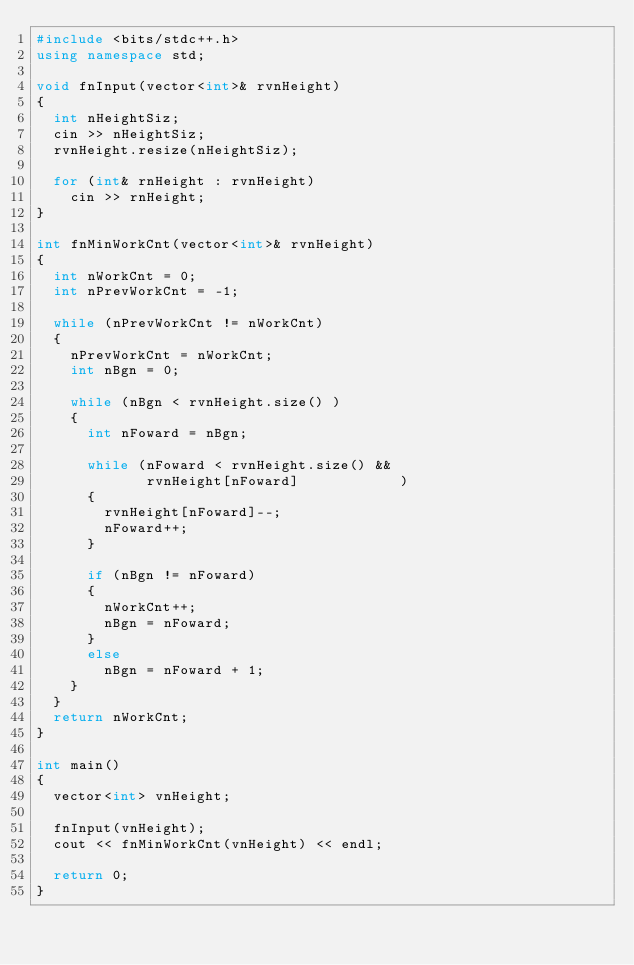<code> <loc_0><loc_0><loc_500><loc_500><_C++_>#include <bits/stdc++.h>
using namespace std;

void fnInput(vector<int>& rvnHeight)
{
  int nHeightSiz;
  cin >> nHeightSiz;
  rvnHeight.resize(nHeightSiz);

  for (int& rnHeight : rvnHeight)
    cin >> rnHeight;
}

int fnMinWorkCnt(vector<int>& rvnHeight)
{
  int nWorkCnt = 0;
  int nPrevWorkCnt = -1;

  while (nPrevWorkCnt != nWorkCnt)
  {
    nPrevWorkCnt = nWorkCnt;
    int nBgn = 0;
  
    while (nBgn < rvnHeight.size() )
    {
      int nFoward = nBgn;

      while (nFoward < rvnHeight.size() &&
             rvnHeight[nFoward]            )
      {
        rvnHeight[nFoward]--;
        nFoward++;
      }

      if (nBgn != nFoward)
      {
        nWorkCnt++;
        nBgn = nFoward;
      }
      else
        nBgn = nFoward + 1;
    }
  }
  return nWorkCnt;
}
 
int main()
{
  vector<int> vnHeight;

  fnInput(vnHeight);
  cout << fnMinWorkCnt(vnHeight) << endl;

  return 0;
}</code> 